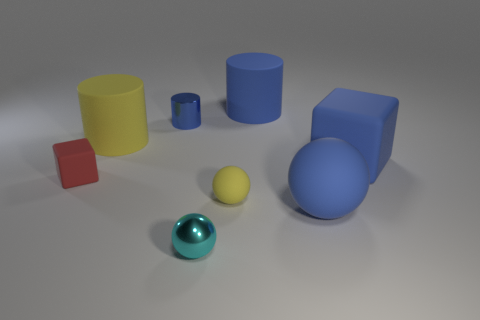Is there a cube of the same size as the cyan sphere?
Ensure brevity in your answer.  Yes. How many things are either cubes to the left of the cyan metallic object or yellow rubber objects?
Your answer should be very brief. 3. Is the big yellow cylinder made of the same material as the tiny thing in front of the tiny yellow rubber ball?
Make the answer very short. No. How many other objects are there of the same shape as the small cyan thing?
Your answer should be compact. 2. How many objects are either cylinders to the right of the tiny yellow rubber sphere or blue things behind the tiny red cube?
Your answer should be very brief. 3. What number of other things are the same color as the tiny block?
Provide a succinct answer. 0. Is the number of tiny balls behind the big blue rubber cylinder less than the number of red blocks in front of the red matte thing?
Your answer should be very brief. No. What number of small cylinders are there?
Provide a short and direct response. 1. There is a blue thing that is the same shape as the tiny yellow matte thing; what is it made of?
Provide a short and direct response. Rubber. Are there fewer tiny red things that are on the right side of the large blue rubber cylinder than blue matte cubes?
Provide a short and direct response. Yes. 